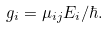<formula> <loc_0><loc_0><loc_500><loc_500>g _ { i } = \mu _ { i j } E _ { i } / \hbar { . }</formula> 